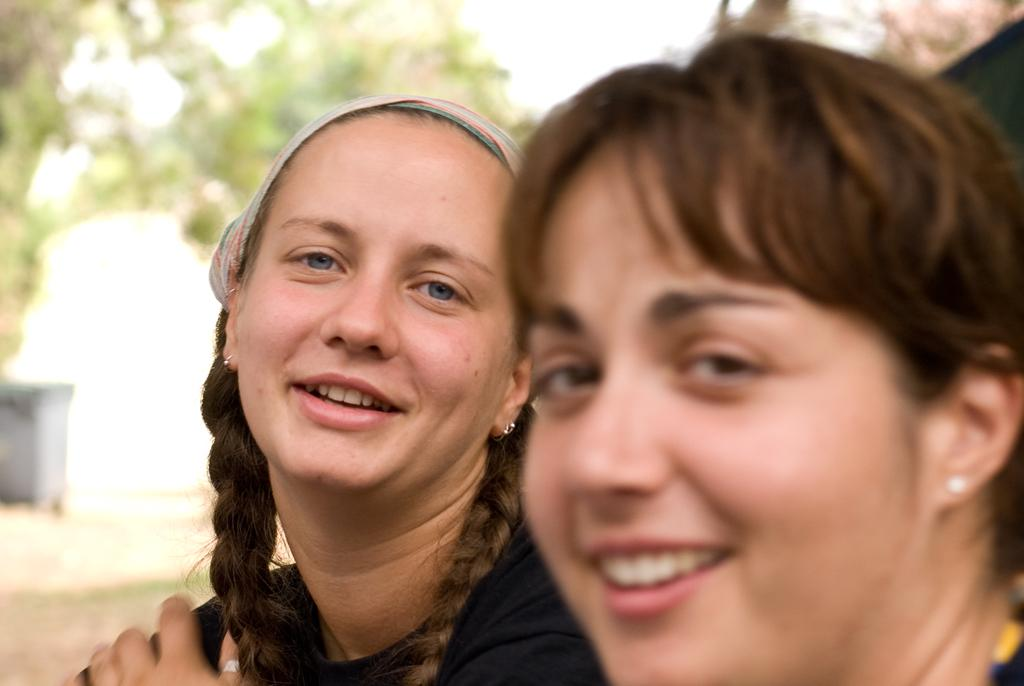What is the position of the woman on the left side of the image? The woman on the left side of the image is on the left side. What is the facial expression of the woman on the left side? The woman on the left side is smiling. What is the woman on the left side doing? The woman on the left side is watching something. What is the position of the woman on the right side of the image? The woman on the right side of the image is on the right side. What is the facial expression of the woman on the right side? The woman on the right side is smiling. What is the woman on the right side doing? The woman on the right side is watching something. How would you describe the background of the image? The background of the image is blurred. What type of snail can be seen crawling on the woman's shoulder in the image? There is no snail present in the image; both women are focused on watching something. 